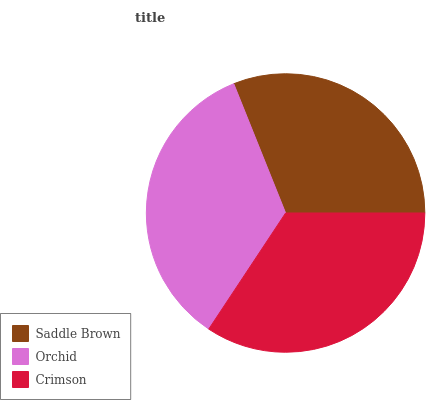Is Saddle Brown the minimum?
Answer yes or no. Yes. Is Orchid the maximum?
Answer yes or no. Yes. Is Crimson the minimum?
Answer yes or no. No. Is Crimson the maximum?
Answer yes or no. No. Is Orchid greater than Crimson?
Answer yes or no. Yes. Is Crimson less than Orchid?
Answer yes or no. Yes. Is Crimson greater than Orchid?
Answer yes or no. No. Is Orchid less than Crimson?
Answer yes or no. No. Is Crimson the high median?
Answer yes or no. Yes. Is Crimson the low median?
Answer yes or no. Yes. Is Orchid the high median?
Answer yes or no. No. Is Saddle Brown the low median?
Answer yes or no. No. 